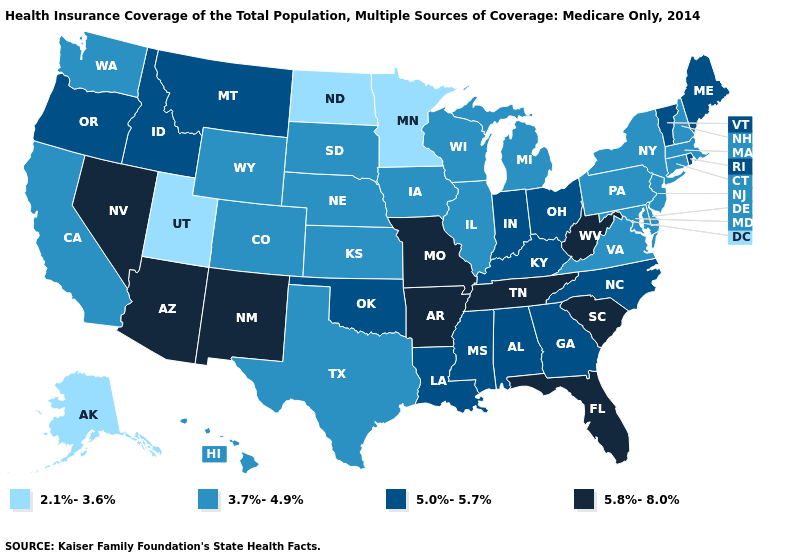Does Alabama have a higher value than New York?
Answer briefly. Yes. Which states have the highest value in the USA?
Be succinct. Arizona, Arkansas, Florida, Missouri, Nevada, New Mexico, South Carolina, Tennessee, West Virginia. What is the value of Connecticut?
Concise answer only. 3.7%-4.9%. Which states have the lowest value in the South?
Answer briefly. Delaware, Maryland, Texas, Virginia. Does the first symbol in the legend represent the smallest category?
Concise answer only. Yes. Does the first symbol in the legend represent the smallest category?
Be succinct. Yes. Among the states that border Missouri , which have the highest value?
Concise answer only. Arkansas, Tennessee. What is the value of Nevada?
Be succinct. 5.8%-8.0%. Among the states that border New Mexico , does Utah have the lowest value?
Be succinct. Yes. What is the highest value in the USA?
Write a very short answer. 5.8%-8.0%. What is the highest value in the Northeast ?
Answer briefly. 5.0%-5.7%. Does Georgia have the same value as Indiana?
Short answer required. Yes. Which states have the lowest value in the USA?
Answer briefly. Alaska, Minnesota, North Dakota, Utah. Does Nevada have a lower value than Michigan?
Concise answer only. No. Does Hawaii have the same value as Utah?
Short answer required. No. 